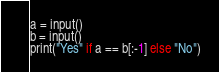<code> <loc_0><loc_0><loc_500><loc_500><_Python_>a = input()
b = input()
print("Yes" if a == b[:-1] else "No")
</code> 